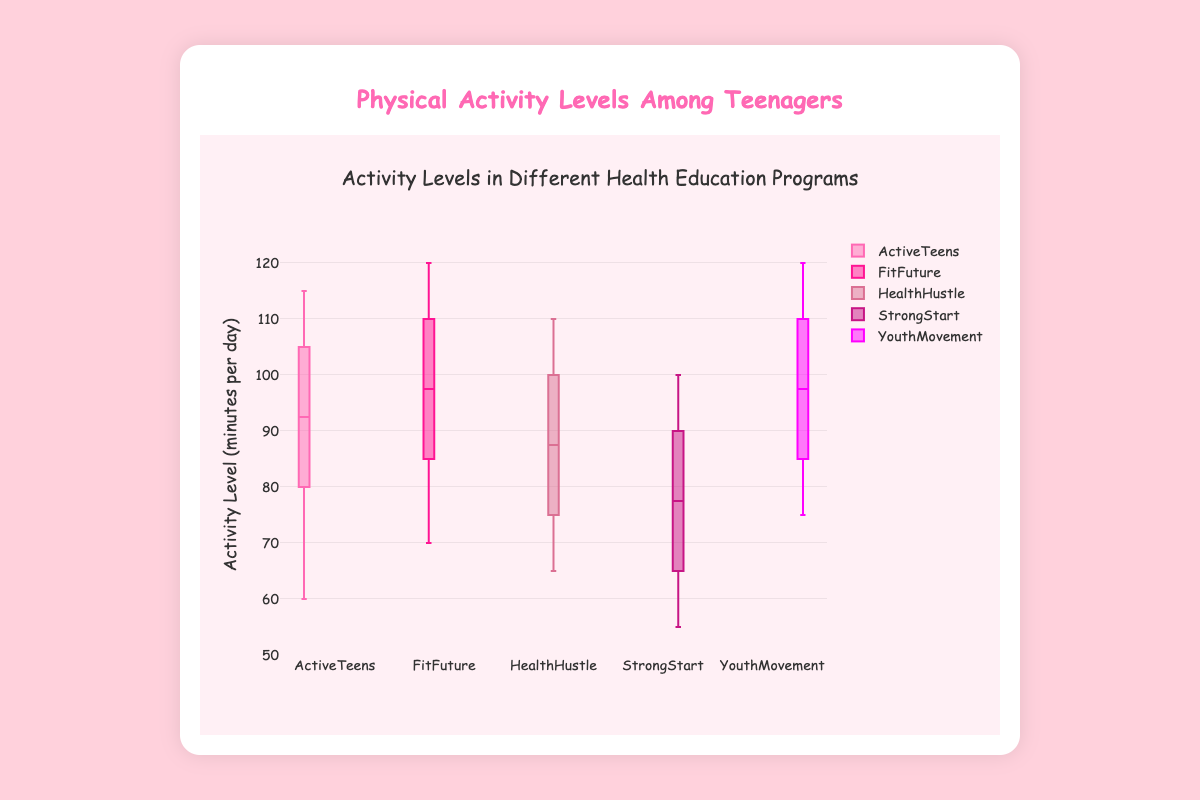what's the title of the plot? The title is always displayed at the top of a plot, helping viewers understand what data is being presented. Here, it reads "Activity Levels in Different Health Education Programs".
Answer: Activity Levels in Different Health Education Programs which program has the highest maximum activity level? The maximum value is the highest point of the whiskers in a box plot. For "FitFuture" and "YouthMovement", the maximum value is 120.
Answer: FitFuture and YouthMovement what's the median activity level for the "ActiveTeens" program? The median is represented by the line that divides the box into two parts. For "ActiveTeens", it's between 90 and 95 minutes per day.
Answer: Around 95 minutes per day which program shows the lowest minimum activity level? The minimum value is the lowest point of the whiskers in the box plot. For "StrongStart", it is 55 minutes per day.
Answer: StrongStart what's the interquartile range (IQR) of the "HealthHustle" program? The IQR is the range between the 25th percentile (bottom of the box) and the 75th percentile (top of the box). For "HealthHustle", it is between 75 and 95 minutes per day.
Answer: 20 minutes per day how do the medians of "FitFuture" and "YouthMovement" compare? The medians are represented by the line inside each box. Both "FitFuture" and "YouthMovement" have their medians at the same level, around 100.
Answer: They are equal which program has the widest spread of activity levels? The spread can be determined by the distance between the minimum and maximum values. "YouthMovement" and "FitFuture" both range between 75 and 120 minutes per day.
Answer: YouthMovement and FitFuture what's the color of the "StrongStart" box plot? The color of the box plot helps in identifying it easily. "StrongStart" is colored in a shade of purple.
Answer: A shade of purple how does the range of "ActiveTeens" compare with "HealthHustle"? The range is the difference between the minimum and maximum values. "ActiveTeens" ranges from 60 to 115, and "HealthHustle" ranges from 65 to 110. So, "ActiveTeens" has a slightly wider range.
Answer: ActiveTeens has a wider range 